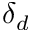<formula> <loc_0><loc_0><loc_500><loc_500>\delta _ { d }</formula> 